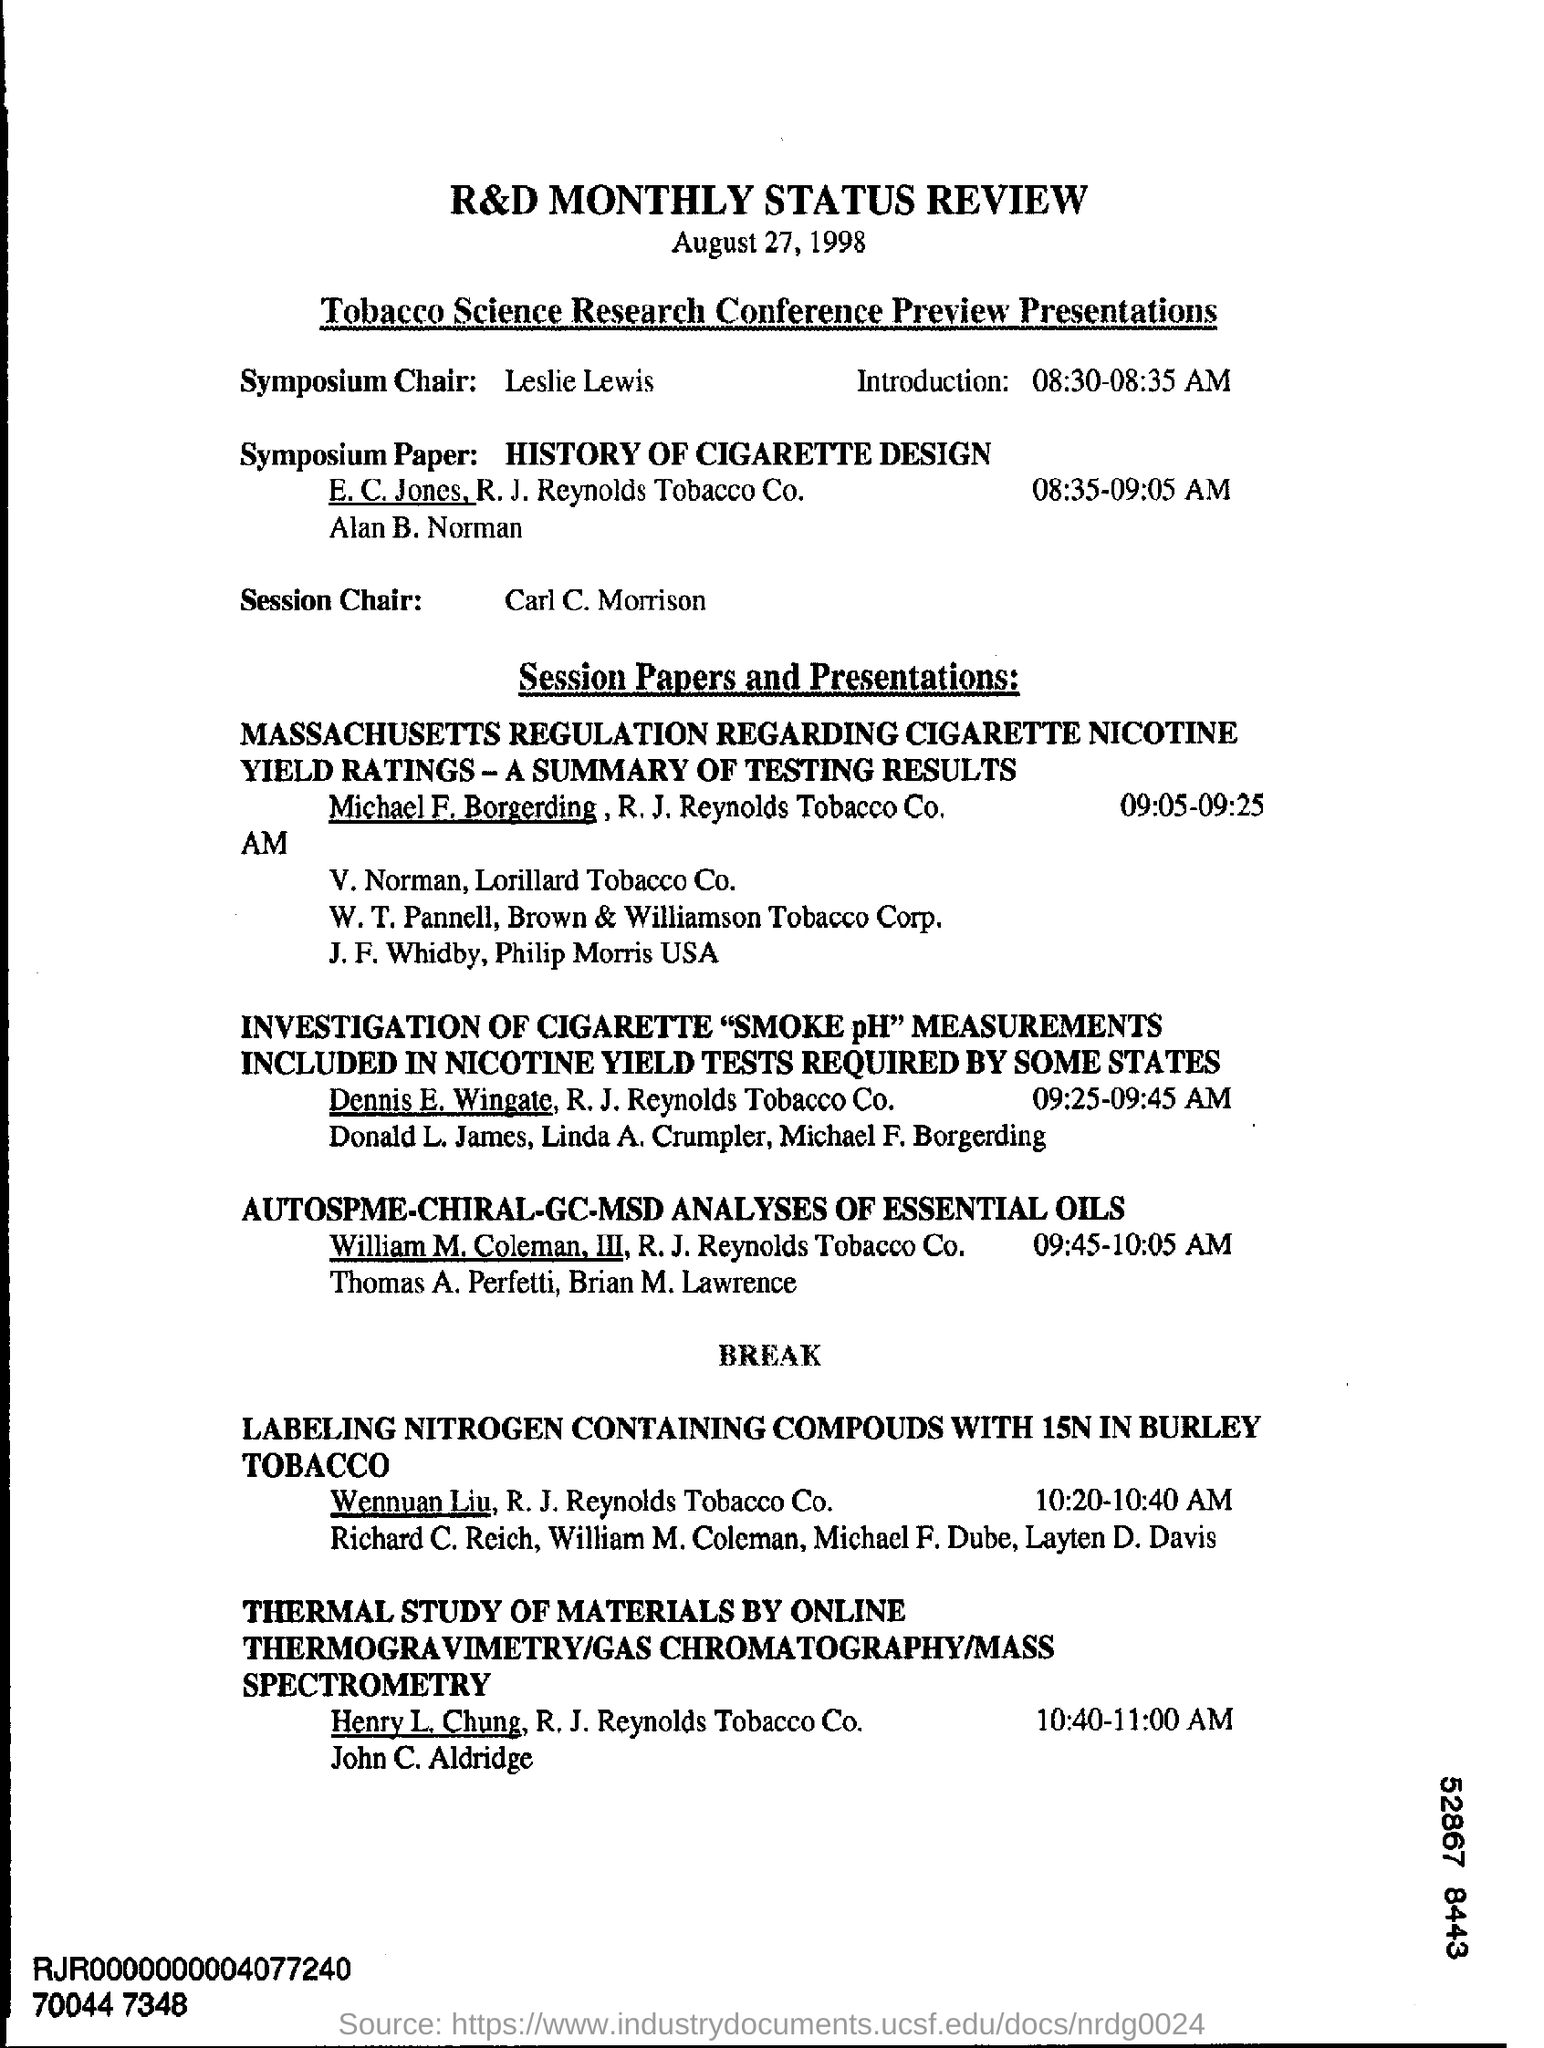Outline some significant characteristics in this image. The date that is being referred to is August 27, 1998. The Symposium Chair is Leslie Lewis. The Session Chair is Carl C. Morrison. 